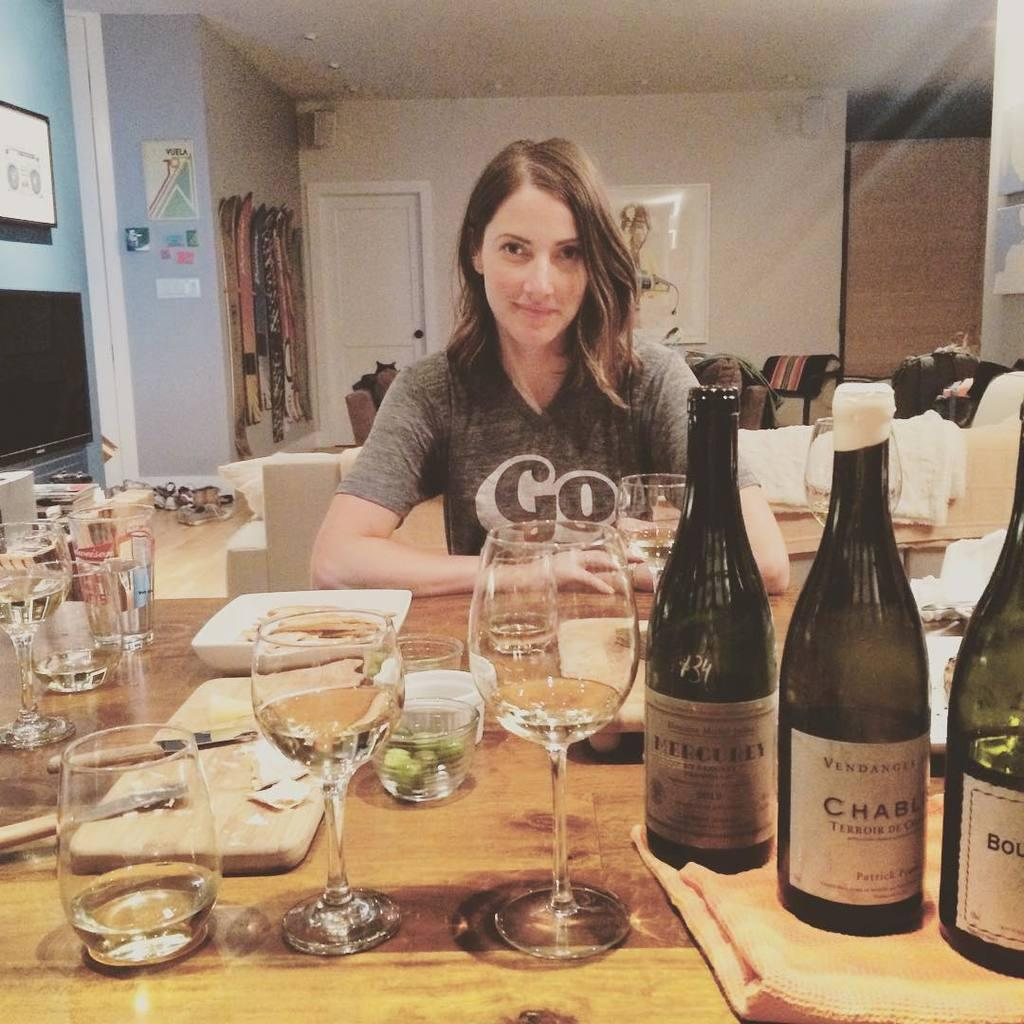<image>
Summarize the visual content of the image. a woman wearing a grey shirt at a table that says 'go' on it 